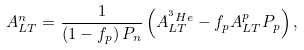<formula> <loc_0><loc_0><loc_500><loc_500>A _ { L T } ^ { n } = \frac { 1 } { \left ( 1 - f _ { p } \right ) P _ { n } } \left ( A _ { L T } ^ { ^ { 3 } H e } - f _ { p } A _ { L T } ^ { p } P _ { p } \right ) ,</formula> 